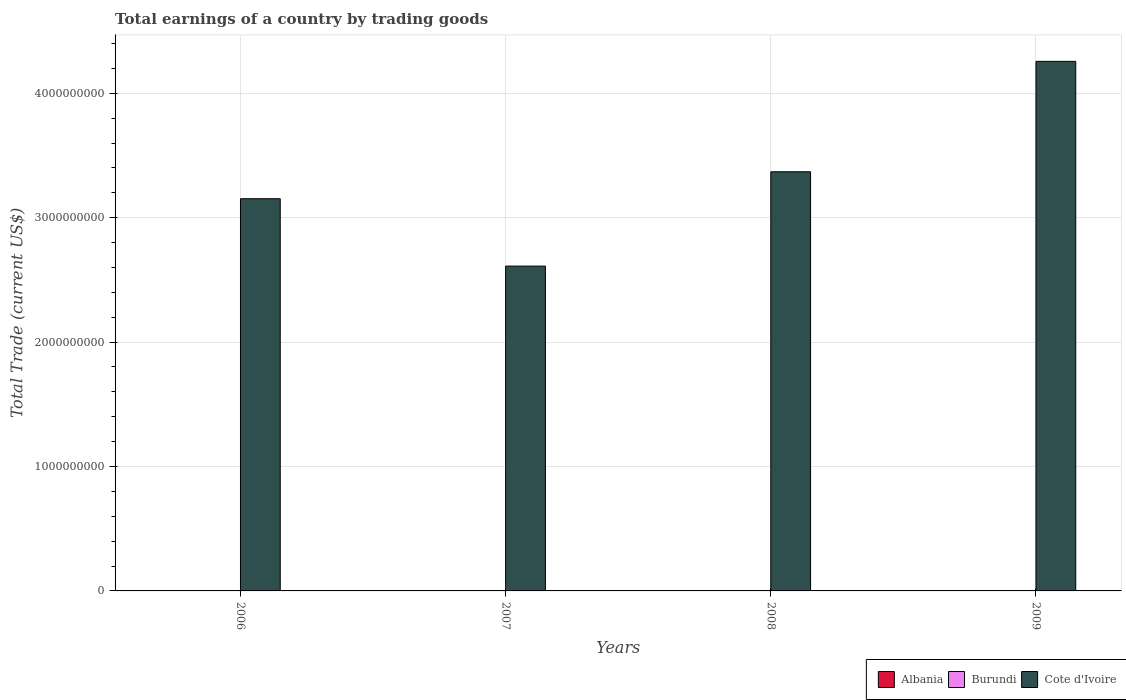How many different coloured bars are there?
Offer a very short reply. 1. Are the number of bars on each tick of the X-axis equal?
Your answer should be very brief. Yes. In how many cases, is the number of bars for a given year not equal to the number of legend labels?
Make the answer very short. 4. What is the total earnings in Cote d'Ivoire in 2008?
Provide a short and direct response. 3.37e+09. What is the difference between the total earnings in Cote d'Ivoire in 2007 and that in 2009?
Ensure brevity in your answer.  -1.65e+09. What is the difference between the total earnings in Cote d'Ivoire in 2009 and the total earnings in Burundi in 2006?
Make the answer very short. 4.26e+09. In how many years, is the total earnings in Burundi greater than 800000000 US$?
Keep it short and to the point. 0. What is the ratio of the total earnings in Cote d'Ivoire in 2006 to that in 2008?
Provide a short and direct response. 0.94. Is the total earnings in Cote d'Ivoire in 2006 less than that in 2008?
Offer a terse response. Yes. What is the difference between the highest and the second highest total earnings in Cote d'Ivoire?
Your response must be concise. 8.88e+08. What is the difference between the highest and the lowest total earnings in Cote d'Ivoire?
Offer a very short reply. 1.65e+09. In how many years, is the total earnings in Albania greater than the average total earnings in Albania taken over all years?
Keep it short and to the point. 0. Is the sum of the total earnings in Cote d'Ivoire in 2006 and 2009 greater than the maximum total earnings in Burundi across all years?
Offer a very short reply. Yes. Is it the case that in every year, the sum of the total earnings in Burundi and total earnings in Albania is greater than the total earnings in Cote d'Ivoire?
Give a very brief answer. No. How many bars are there?
Ensure brevity in your answer.  4. How many years are there in the graph?
Give a very brief answer. 4. What is the difference between two consecutive major ticks on the Y-axis?
Ensure brevity in your answer.  1.00e+09. Does the graph contain grids?
Your answer should be compact. Yes. Where does the legend appear in the graph?
Offer a very short reply. Bottom right. How many legend labels are there?
Provide a short and direct response. 3. How are the legend labels stacked?
Offer a terse response. Horizontal. What is the title of the graph?
Give a very brief answer. Total earnings of a country by trading goods. Does "Moldova" appear as one of the legend labels in the graph?
Ensure brevity in your answer.  No. What is the label or title of the Y-axis?
Give a very brief answer. Total Trade (current US$). What is the Total Trade (current US$) of Cote d'Ivoire in 2006?
Offer a terse response. 3.15e+09. What is the Total Trade (current US$) of Burundi in 2007?
Your answer should be compact. 0. What is the Total Trade (current US$) of Cote d'Ivoire in 2007?
Provide a succinct answer. 2.61e+09. What is the Total Trade (current US$) in Burundi in 2008?
Keep it short and to the point. 0. What is the Total Trade (current US$) of Cote d'Ivoire in 2008?
Offer a terse response. 3.37e+09. What is the Total Trade (current US$) of Albania in 2009?
Your answer should be very brief. 0. What is the Total Trade (current US$) of Cote d'Ivoire in 2009?
Your answer should be compact. 4.26e+09. Across all years, what is the maximum Total Trade (current US$) of Cote d'Ivoire?
Your response must be concise. 4.26e+09. Across all years, what is the minimum Total Trade (current US$) of Cote d'Ivoire?
Give a very brief answer. 2.61e+09. What is the total Total Trade (current US$) in Burundi in the graph?
Ensure brevity in your answer.  0. What is the total Total Trade (current US$) in Cote d'Ivoire in the graph?
Offer a terse response. 1.34e+1. What is the difference between the Total Trade (current US$) of Cote d'Ivoire in 2006 and that in 2007?
Offer a terse response. 5.42e+08. What is the difference between the Total Trade (current US$) of Cote d'Ivoire in 2006 and that in 2008?
Ensure brevity in your answer.  -2.17e+08. What is the difference between the Total Trade (current US$) of Cote d'Ivoire in 2006 and that in 2009?
Your answer should be compact. -1.10e+09. What is the difference between the Total Trade (current US$) in Cote d'Ivoire in 2007 and that in 2008?
Keep it short and to the point. -7.58e+08. What is the difference between the Total Trade (current US$) of Cote d'Ivoire in 2007 and that in 2009?
Your answer should be very brief. -1.65e+09. What is the difference between the Total Trade (current US$) in Cote d'Ivoire in 2008 and that in 2009?
Provide a short and direct response. -8.88e+08. What is the average Total Trade (current US$) in Albania per year?
Offer a very short reply. 0. What is the average Total Trade (current US$) in Burundi per year?
Make the answer very short. 0. What is the average Total Trade (current US$) in Cote d'Ivoire per year?
Your answer should be very brief. 3.35e+09. What is the ratio of the Total Trade (current US$) of Cote d'Ivoire in 2006 to that in 2007?
Your response must be concise. 1.21. What is the ratio of the Total Trade (current US$) of Cote d'Ivoire in 2006 to that in 2008?
Provide a succinct answer. 0.94. What is the ratio of the Total Trade (current US$) of Cote d'Ivoire in 2006 to that in 2009?
Offer a very short reply. 0.74. What is the ratio of the Total Trade (current US$) in Cote d'Ivoire in 2007 to that in 2008?
Provide a short and direct response. 0.78. What is the ratio of the Total Trade (current US$) in Cote d'Ivoire in 2007 to that in 2009?
Your answer should be very brief. 0.61. What is the ratio of the Total Trade (current US$) in Cote d'Ivoire in 2008 to that in 2009?
Your answer should be very brief. 0.79. What is the difference between the highest and the second highest Total Trade (current US$) in Cote d'Ivoire?
Your answer should be compact. 8.88e+08. What is the difference between the highest and the lowest Total Trade (current US$) of Cote d'Ivoire?
Ensure brevity in your answer.  1.65e+09. 